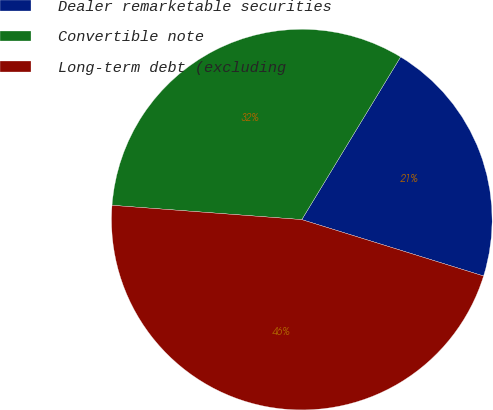<chart> <loc_0><loc_0><loc_500><loc_500><pie_chart><fcel>Dealer remarketable securities<fcel>Convertible note<fcel>Long-term debt (excluding<nl><fcel>21.1%<fcel>32.49%<fcel>46.41%<nl></chart> 